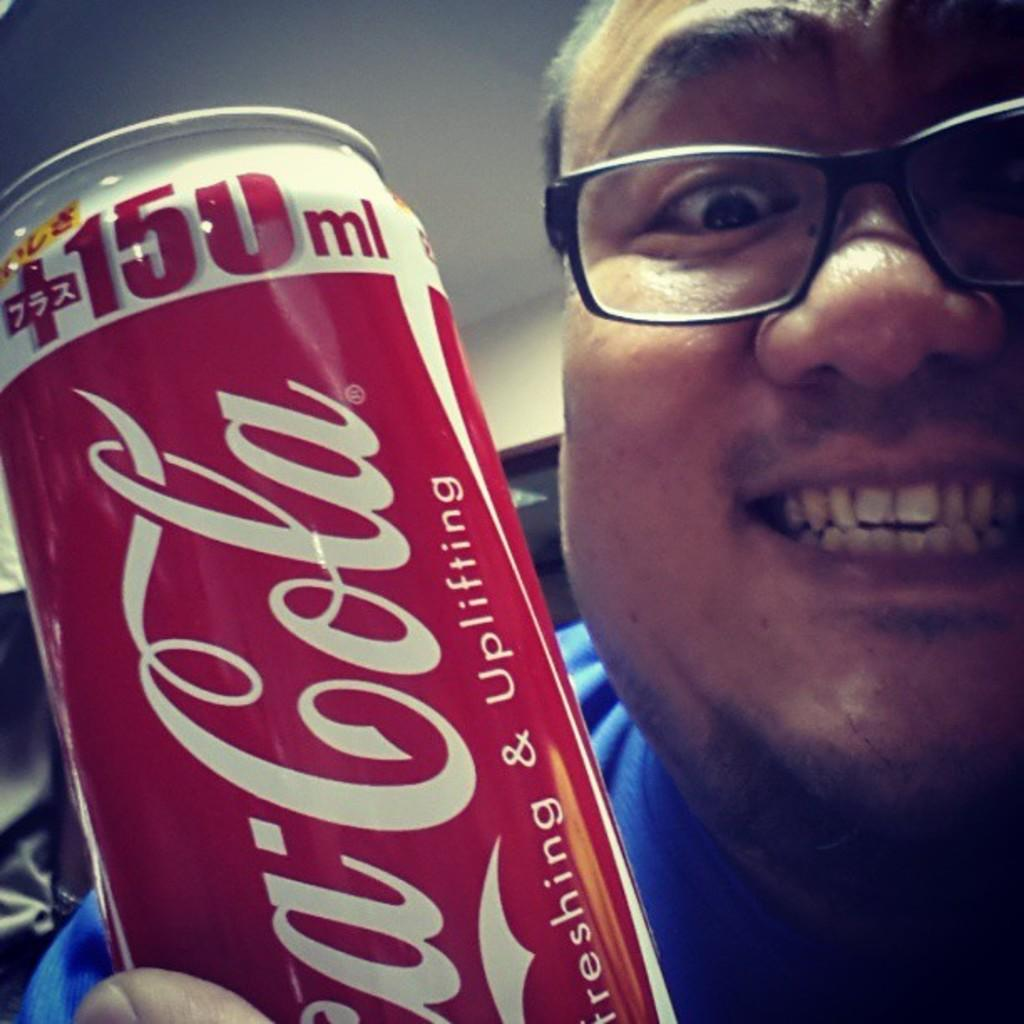<image>
Summarize the visual content of the image. A guy with glasses on smiling holding a can of Coca-Cola 150ml that says refreshing and uplifting. 